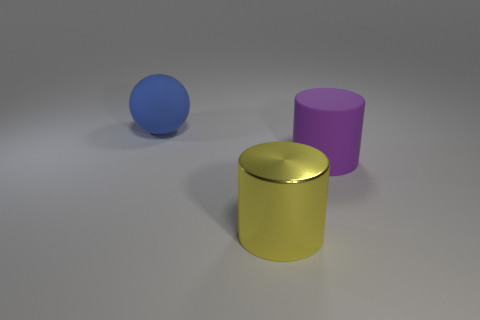Is there any other thing that has the same material as the large yellow thing?
Provide a succinct answer. No. Does the large object behind the large purple matte cylinder have the same material as the cylinder that is behind the shiny thing?
Offer a terse response. Yes. How many big cylinders are right of the yellow cylinder?
Offer a terse response. 1. How many purple things are big matte cylinders or big metallic things?
Keep it short and to the point. 1. There is a yellow cylinder that is the same size as the blue rubber sphere; what is its material?
Give a very brief answer. Metal. There is a large thing that is both to the left of the big matte cylinder and behind the yellow thing; what is its shape?
Your answer should be compact. Sphere. What color is the ball that is the same size as the yellow cylinder?
Provide a short and direct response. Blue. Do the object that is to the left of the yellow cylinder and the object in front of the matte cylinder have the same size?
Your answer should be very brief. Yes. How big is the matte object that is in front of the rubber object that is on the left side of the rubber thing that is right of the blue rubber sphere?
Offer a terse response. Large. There is a large rubber object that is to the right of the big thing in front of the purple matte object; what is its shape?
Give a very brief answer. Cylinder. 